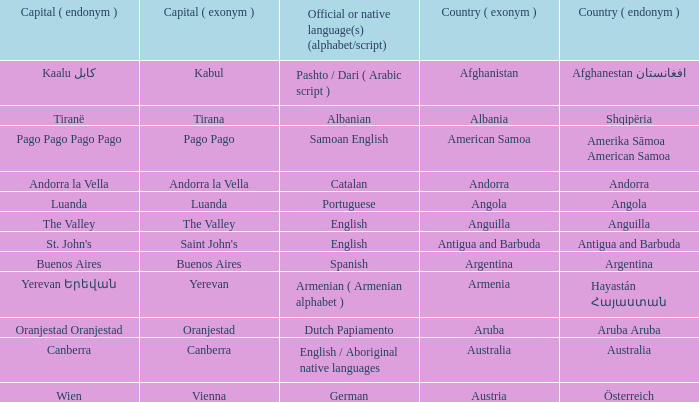Can you parse all the data within this table? {'header': ['Capital ( endonym )', 'Capital ( exonym )', 'Official or native language(s) (alphabet/script)', 'Country ( exonym )', 'Country ( endonym )'], 'rows': [['Kaalu كابل', 'Kabul', 'Pashto / Dari ( Arabic script )', 'Afghanistan', 'Afghanestan افغانستان'], ['Tiranë', 'Tirana', 'Albanian', 'Albania', 'Shqipëria'], ['Pago Pago Pago Pago', 'Pago Pago', 'Samoan English', 'American Samoa', 'Amerika Sāmoa American Samoa'], ['Andorra la Vella', 'Andorra la Vella', 'Catalan', 'Andorra', 'Andorra'], ['Luanda', 'Luanda', 'Portuguese', 'Angola', 'Angola'], ['The Valley', 'The Valley', 'English', 'Anguilla', 'Anguilla'], ["St. John's", "Saint John's", 'English', 'Antigua and Barbuda', 'Antigua and Barbuda'], ['Buenos Aires', 'Buenos Aires', 'Spanish', 'Argentina', 'Argentina'], ['Yerevan Երեվան', 'Yerevan', 'Armenian ( Armenian alphabet )', 'Armenia', 'Hayastán Հայաստան'], ['Oranjestad Oranjestad', 'Oranjestad', 'Dutch Papiamento', 'Aruba', 'Aruba Aruba'], ['Canberra', 'Canberra', 'English / Aboriginal native languages', 'Australia', 'Australia'], ['Wien', 'Vienna', 'German', 'Austria', 'Österreich']]} What is the local name given to the capital of Anguilla? The Valley. 